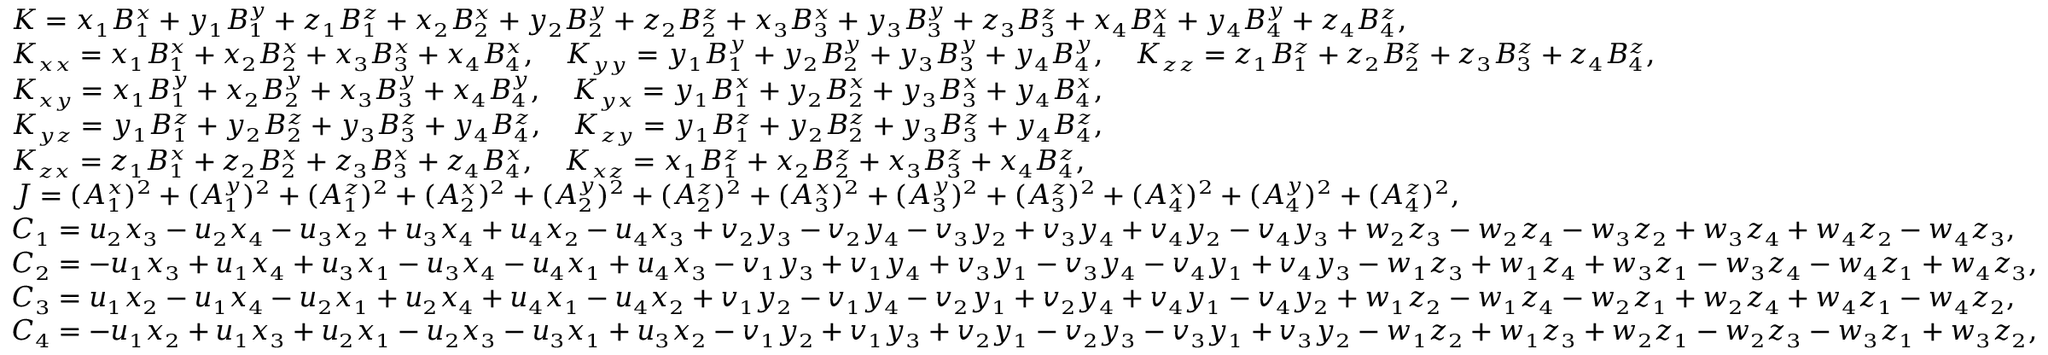Convert formula to latex. <formula><loc_0><loc_0><loc_500><loc_500>\begin{array} { r l } & { K = x _ { 1 } B _ { 1 } ^ { x } + y _ { 1 } B _ { 1 } ^ { y } + z _ { 1 } B _ { 1 } ^ { z } + x _ { 2 } B _ { 2 } ^ { x } + y _ { 2 } B _ { 2 } ^ { y } + z _ { 2 } B _ { 2 } ^ { z } + x _ { 3 } B _ { 3 } ^ { x } + y _ { 3 } B _ { 3 } ^ { y } + z _ { 3 } B _ { 3 } ^ { z } + x _ { 4 } B _ { 4 } ^ { x } + y _ { 4 } B _ { 4 } ^ { y } + z _ { 4 } B _ { 4 } ^ { z } , } \\ & { K _ { x x } = x _ { 1 } B _ { 1 } ^ { x } + x _ { 2 } B _ { 2 } ^ { x } + x _ { 3 } B _ { 3 } ^ { x } + x _ { 4 } B _ { 4 } ^ { x } , \quad K _ { y y } = y _ { 1 } B _ { 1 } ^ { y } + y _ { 2 } B _ { 2 } ^ { y } + y _ { 3 } B _ { 3 } ^ { y } + y _ { 4 } B _ { 4 } ^ { y } , \quad K _ { z z } = z _ { 1 } B _ { 1 } ^ { z } + z _ { 2 } B _ { 2 } ^ { z } + z _ { 3 } B _ { 3 } ^ { z } + z _ { 4 } B _ { 4 } ^ { z } , } \\ & { K _ { x y } = x _ { 1 } B _ { 1 } ^ { y } + x _ { 2 } B _ { 2 } ^ { y } + x _ { 3 } B _ { 3 } ^ { y } + x _ { 4 } B _ { 4 } ^ { y } , \quad K _ { y x } = y _ { 1 } B _ { 1 } ^ { x } + y _ { 2 } B _ { 2 } ^ { x } + y _ { 3 } B _ { 3 } ^ { x } + y _ { 4 } B _ { 4 } ^ { x } , } \\ & { K _ { y z } = y _ { 1 } B _ { 1 } ^ { z } + y _ { 2 } B _ { 2 } ^ { z } + y _ { 3 } B _ { 3 } ^ { z } + y _ { 4 } B _ { 4 } ^ { z } , \quad K _ { z y } = y _ { 1 } B _ { 1 } ^ { z } + y _ { 2 } B _ { 2 } ^ { z } + y _ { 3 } B _ { 3 } ^ { z } + y _ { 4 } B _ { 4 } ^ { z } , } \\ & { K _ { z x } = z _ { 1 } B _ { 1 } ^ { x } + z _ { 2 } B _ { 2 } ^ { x } + z _ { 3 } B _ { 3 } ^ { x } + z _ { 4 } B _ { 4 } ^ { x } , \quad K _ { x z } = x _ { 1 } B _ { 1 } ^ { z } + x _ { 2 } B _ { 2 } ^ { z } + x _ { 3 } B _ { 3 } ^ { z } + x _ { 4 } B _ { 4 } ^ { z } , } \\ & { J = ( A _ { 1 } ^ { x } ) ^ { 2 } + ( A _ { 1 } ^ { y } ) ^ { 2 } + ( A _ { 1 } ^ { z } ) ^ { 2 } + ( A _ { 2 } ^ { x } ) ^ { 2 } + ( A _ { 2 } ^ { y } ) ^ { 2 } + ( A _ { 2 } ^ { z } ) ^ { 2 } + ( A _ { 3 } ^ { x } ) ^ { 2 } + ( A _ { 3 } ^ { y } ) ^ { 2 } + ( A _ { 3 } ^ { z } ) ^ { 2 } + ( A _ { 4 } ^ { x } ) ^ { 2 } + ( A _ { 4 } ^ { y } ) ^ { 2 } + ( A _ { 4 } ^ { z } ) ^ { 2 } , } \\ & { C _ { 1 } = u _ { 2 } x _ { 3 } - u _ { 2 } x _ { 4 } - u _ { 3 } x _ { 2 } + u _ { 3 } x _ { 4 } + u _ { 4 } x _ { 2 } - u _ { 4 } x _ { 3 } + v _ { 2 } y _ { 3 } - v _ { 2 } y _ { 4 } - v _ { 3 } y _ { 2 } + v _ { 3 } y _ { 4 } + v _ { 4 } y _ { 2 } - v _ { 4 } y _ { 3 } + w _ { 2 } z _ { 3 } - w _ { 2 } z _ { 4 } - w _ { 3 } z _ { 2 } + w _ { 3 } z _ { 4 } + w _ { 4 } z _ { 2 } - w _ { 4 } z _ { 3 } , } \\ & { C _ { 2 } = - u _ { 1 } x _ { 3 } + u _ { 1 } x _ { 4 } + u _ { 3 } x _ { 1 } - u _ { 3 } x _ { 4 } - u _ { 4 } x _ { 1 } + u _ { 4 } x _ { 3 } - v _ { 1 } y _ { 3 } + v _ { 1 } y _ { 4 } + v _ { 3 } y _ { 1 } - v _ { 3 } y _ { 4 } - v _ { 4 } y _ { 1 } + v _ { 4 } y _ { 3 } - w _ { 1 } z _ { 3 } + w _ { 1 } z _ { 4 } + w _ { 3 } z _ { 1 } - w _ { 3 } z _ { 4 } - w _ { 4 } z _ { 1 } + w _ { 4 } z _ { 3 } , } \\ & { C _ { 3 } = u _ { 1 } x _ { 2 } - u _ { 1 } x _ { 4 } - u _ { 2 } x _ { 1 } + u _ { 2 } x _ { 4 } + u _ { 4 } x _ { 1 } - u _ { 4 } x _ { 2 } + v _ { 1 } y _ { 2 } - v _ { 1 } y _ { 4 } - v _ { 2 } y _ { 1 } + v _ { 2 } y _ { 4 } + v _ { 4 } y _ { 1 } - v _ { 4 } y _ { 2 } + w _ { 1 } z _ { 2 } - w _ { 1 } z _ { 4 } - w _ { 2 } z _ { 1 } + w _ { 2 } z _ { 4 } + w _ { 4 } z _ { 1 } - w _ { 4 } z _ { 2 } , } \\ & { C _ { 4 } = - u _ { 1 } x _ { 2 } + u _ { 1 } x _ { 3 } + u _ { 2 } x _ { 1 } - u _ { 2 } x _ { 3 } - u _ { 3 } x _ { 1 } + u _ { 3 } x _ { 2 } - v _ { 1 } y _ { 2 } + v _ { 1 } y _ { 3 } + v _ { 2 } y _ { 1 } - v _ { 2 } y _ { 3 } - v _ { 3 } y _ { 1 } + v _ { 3 } y _ { 2 } - w _ { 1 } z _ { 2 } + w _ { 1 } z _ { 3 } + w _ { 2 } z _ { 1 } - w _ { 2 } z _ { 3 } - w _ { 3 } z _ { 1 } + w _ { 3 } z _ { 2 } , } \end{array}</formula> 